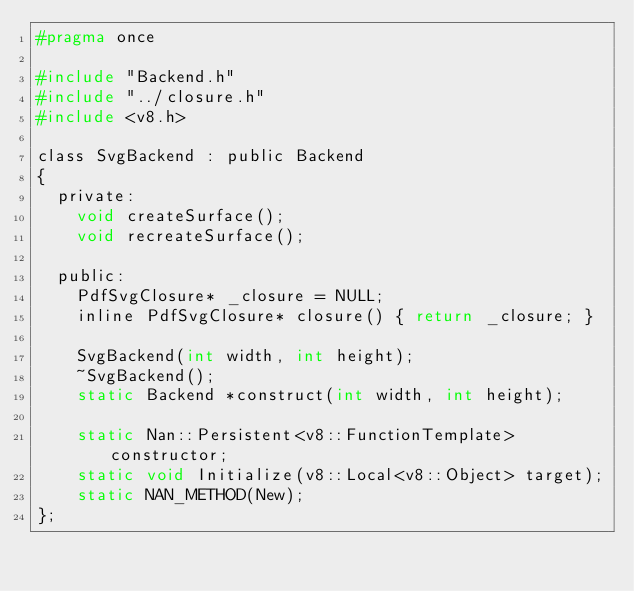<code> <loc_0><loc_0><loc_500><loc_500><_C_>#pragma once

#include "Backend.h"
#include "../closure.h"
#include <v8.h>

class SvgBackend : public Backend
{
  private:
    void createSurface();
    void recreateSurface();

  public:
    PdfSvgClosure* _closure = NULL;
    inline PdfSvgClosure* closure() { return _closure; }

    SvgBackend(int width, int height);
    ~SvgBackend();
    static Backend *construct(int width, int height);

    static Nan::Persistent<v8::FunctionTemplate> constructor;
    static void Initialize(v8::Local<v8::Object> target);
    static NAN_METHOD(New);
};
</code> 